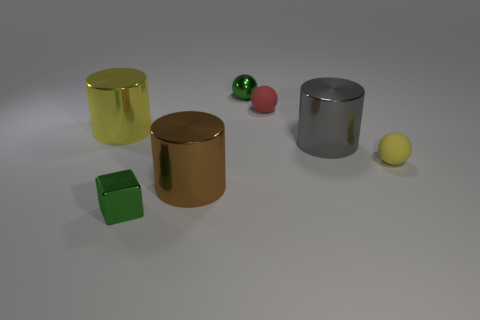Subtract all gray cylinders. How many cylinders are left? 2 Add 1 large green shiny balls. How many objects exist? 8 Subtract 1 cylinders. How many cylinders are left? 2 Subtract all cylinders. How many objects are left? 4 Add 7 tiny yellow balls. How many tiny yellow balls are left? 8 Add 1 tiny brown balls. How many tiny brown balls exist? 1 Subtract 0 gray spheres. How many objects are left? 7 Subtract all tiny metal balls. Subtract all tiny green shiny blocks. How many objects are left? 5 